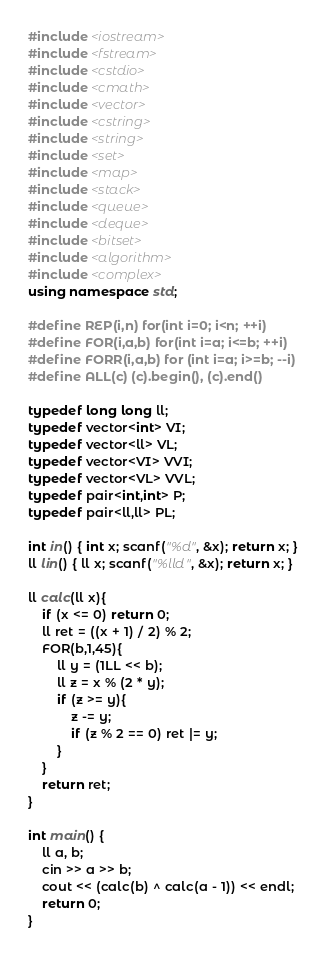<code> <loc_0><loc_0><loc_500><loc_500><_C++_>#include <iostream>
#include <fstream>
#include <cstdio>
#include <cmath>
#include <vector>
#include <cstring>
#include <string>
#include <set>
#include <map>
#include <stack>
#include <queue>
#include <deque>
#include <bitset>
#include <algorithm>
#include <complex>
using namespace std;
 
#define REP(i,n) for(int i=0; i<n; ++i)
#define FOR(i,a,b) for(int i=a; i<=b; ++i)
#define FORR(i,a,b) for (int i=a; i>=b; --i)
#define ALL(c) (c).begin(), (c).end()
 
typedef long long ll;
typedef vector<int> VI;
typedef vector<ll> VL;
typedef vector<VI> VVI;
typedef vector<VL> VVL;
typedef pair<int,int> P;
typedef pair<ll,ll> PL;

int in() { int x; scanf("%d", &x); return x; }
ll lin() { ll x; scanf("%lld", &x); return x; }

ll calc(ll x){
    if (x <= 0) return 0;
    ll ret = ((x + 1) / 2) % 2;
    FOR(b,1,45){
        ll y = (1LL << b);
        ll z = x % (2 * y);
        if (z >= y){
            z -= y;
            if (z % 2 == 0) ret |= y;
        }
    }
    return ret;
}

int main() {
    ll a, b;
    cin >> a >> b;
    cout << (calc(b) ^ calc(a - 1)) << endl;
    return 0;
}</code> 